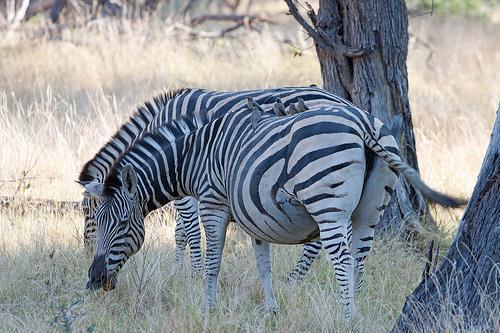How many birds are on the zebra?
Give a very brief answer. 4. How many zebras are there?
Give a very brief answer. 2. How many trees are visible?
Give a very brief answer. 2. How many legs do you see on the first zebra?
Give a very brief answer. 4. 